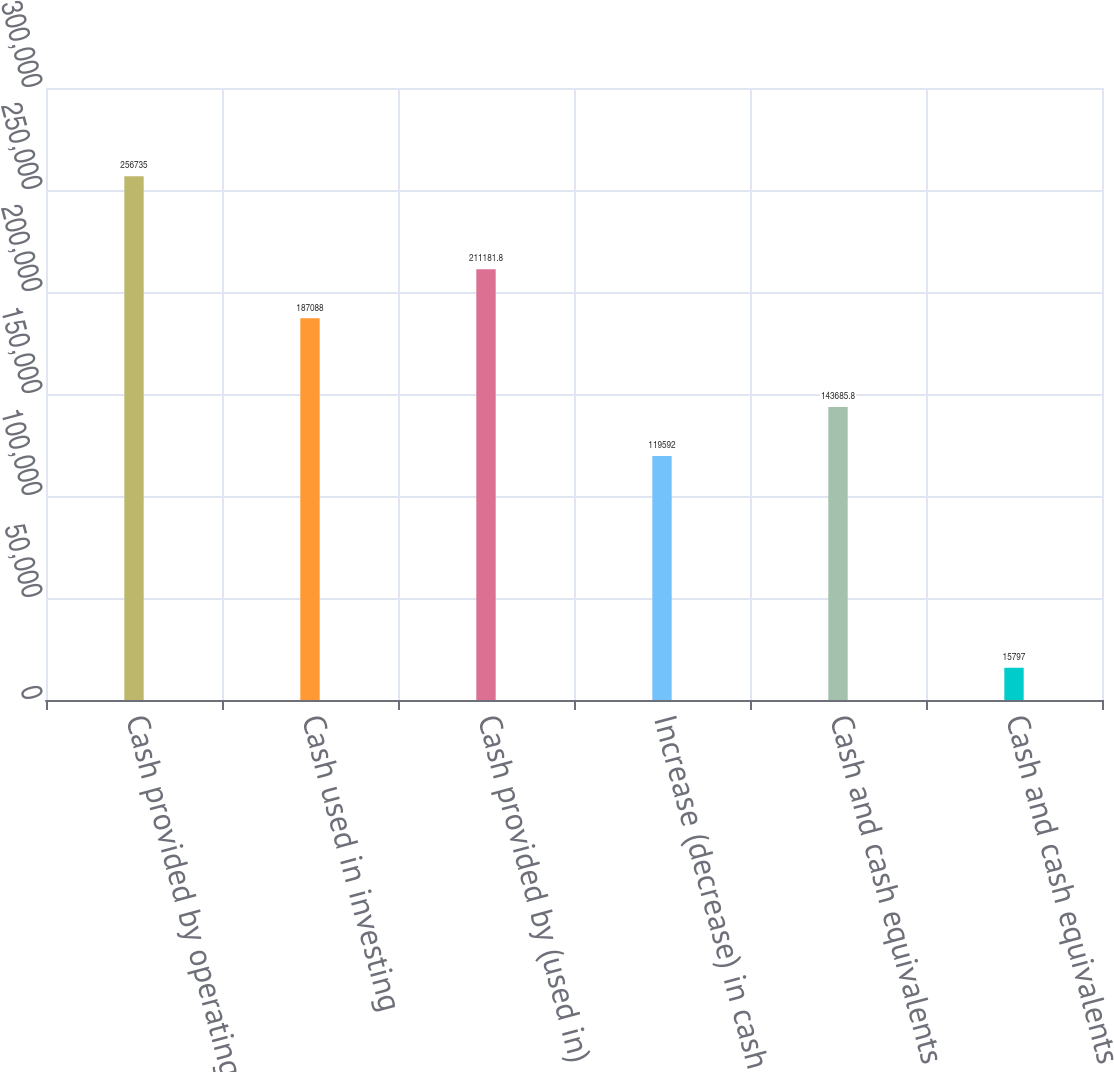Convert chart to OTSL. <chart><loc_0><loc_0><loc_500><loc_500><bar_chart><fcel>Cash provided by operating<fcel>Cash used in investing<fcel>Cash provided by (used in)<fcel>Increase (decrease) in cash<fcel>Cash and cash equivalents<fcel>Cash and cash equivalents end<nl><fcel>256735<fcel>187088<fcel>211182<fcel>119592<fcel>143686<fcel>15797<nl></chart> 